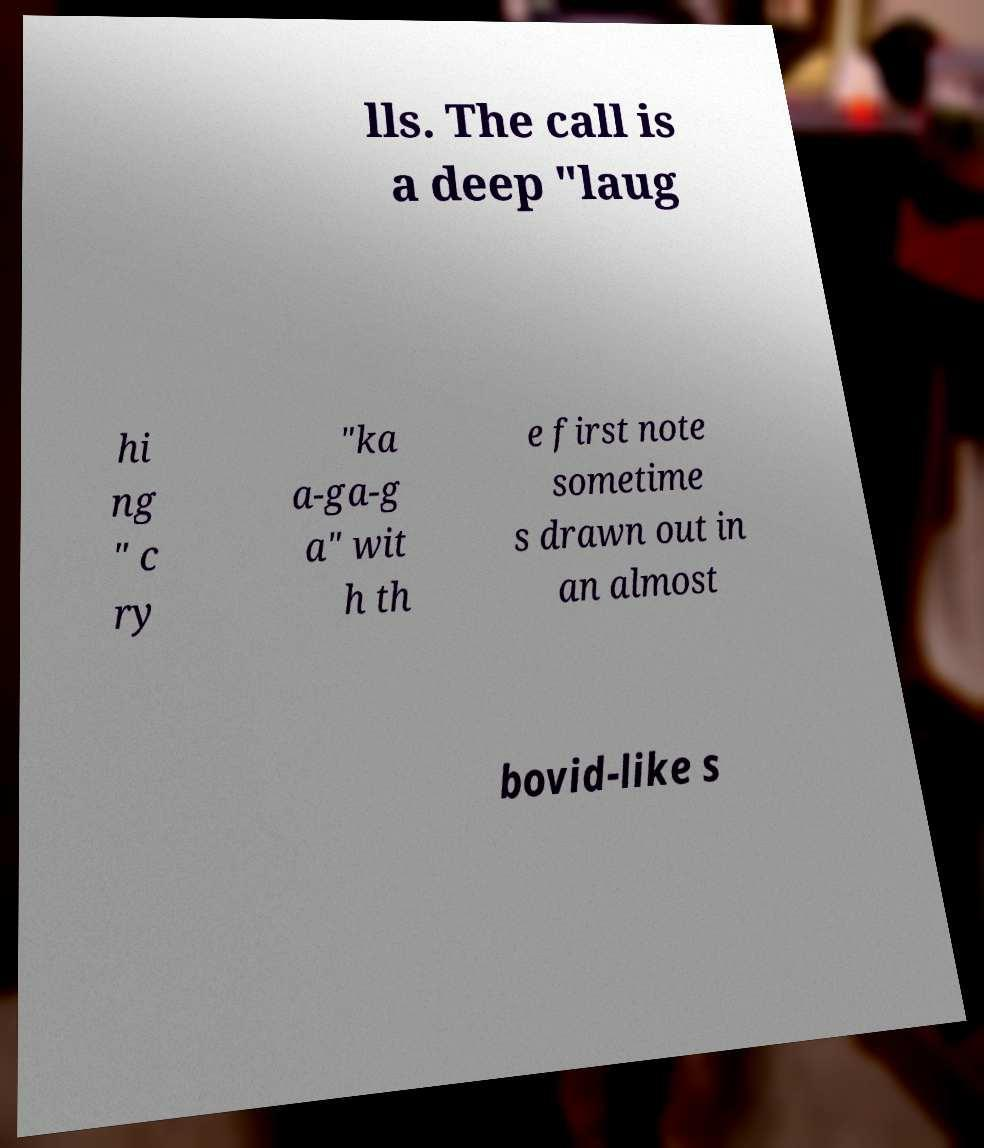What messages or text are displayed in this image? I need them in a readable, typed format. lls. The call is a deep "laug hi ng " c ry "ka a-ga-g a" wit h th e first note sometime s drawn out in an almost bovid-like s 